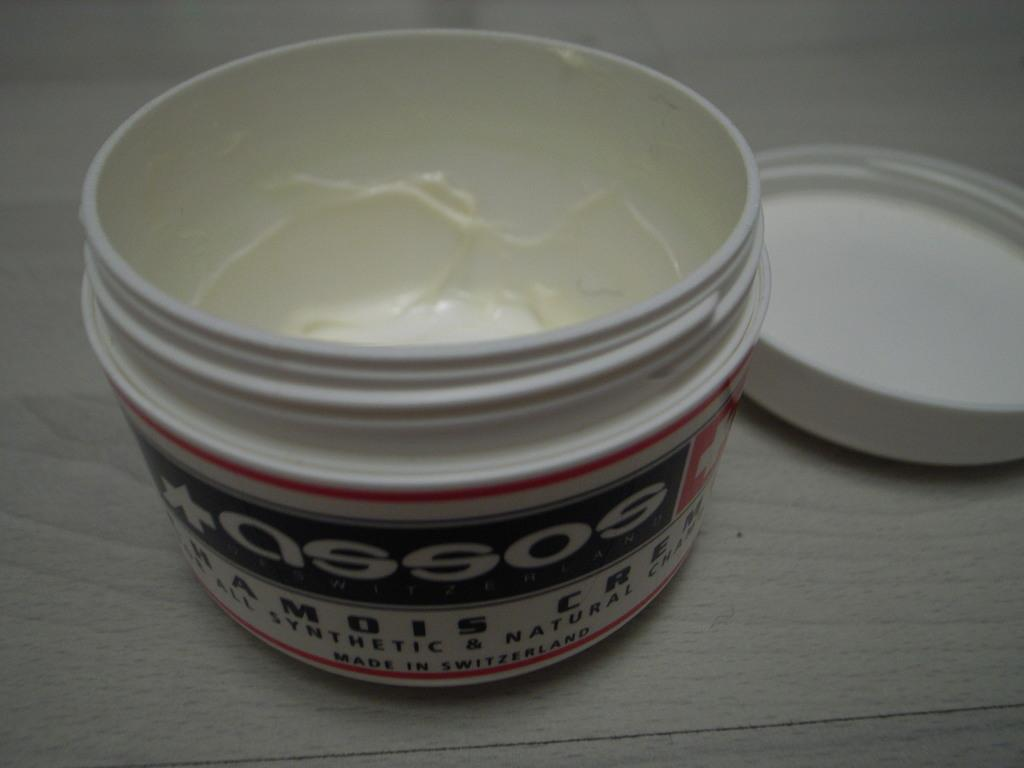<image>
Share a concise interpretation of the image provided. A jar of  a open cream  made in Switzerland 